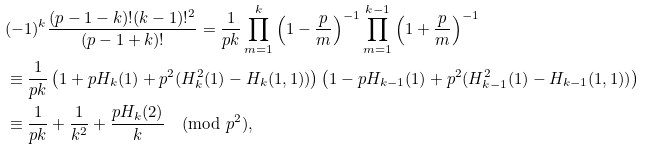Convert formula to latex. <formula><loc_0><loc_0><loc_500><loc_500>& ( - 1 ) ^ { k } \frac { ( p - 1 - k ) ! ( k - 1 ) ! ^ { 2 } } { ( p - 1 + k ) ! } = \frac { 1 } { p k } \prod _ { m = 1 } ^ { k } \left ( 1 - \frac { p } { m } \right ) ^ { - 1 } \prod _ { m = 1 } ^ { k - 1 } \left ( 1 + \frac { p } { m } \right ) ^ { - 1 } \\ & \equiv \frac { 1 } { p k } \left ( 1 + p H _ { k } ( 1 ) + p ^ { 2 } ( H _ { k } ^ { 2 } ( 1 ) - H _ { k } ( 1 , 1 ) ) \right ) \left ( 1 - p H _ { k - 1 } ( 1 ) + p ^ { 2 } ( H _ { k - 1 } ^ { 2 } ( 1 ) - H _ { k - 1 } ( 1 , 1 ) ) \right ) \\ & \equiv \frac { 1 } { p k } + \frac { 1 } { k ^ { 2 } } + \frac { p H _ { k } ( 2 ) } { k } \pmod { p ^ { 2 } } ,</formula> 